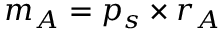<formula> <loc_0><loc_0><loc_500><loc_500>m _ { A } = p _ { s } \times r _ { A }</formula> 